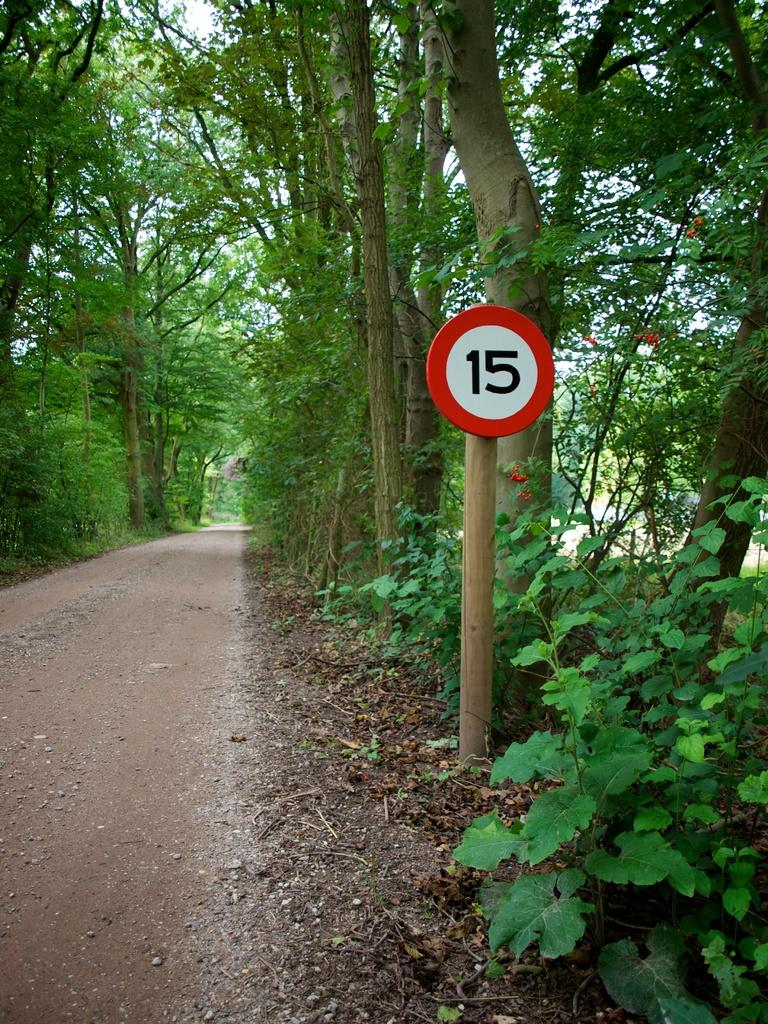What is the main feature of the image? There is a road in the image. What can be seen on both sides of the road? There are trees on both sides of the road. What other object is present in the image? There is a number pole in the image. What type of cabbage is being used to play a game on the side of the road? There is no cabbage or game present in the image; it only features a road, trees, and a number pole. 